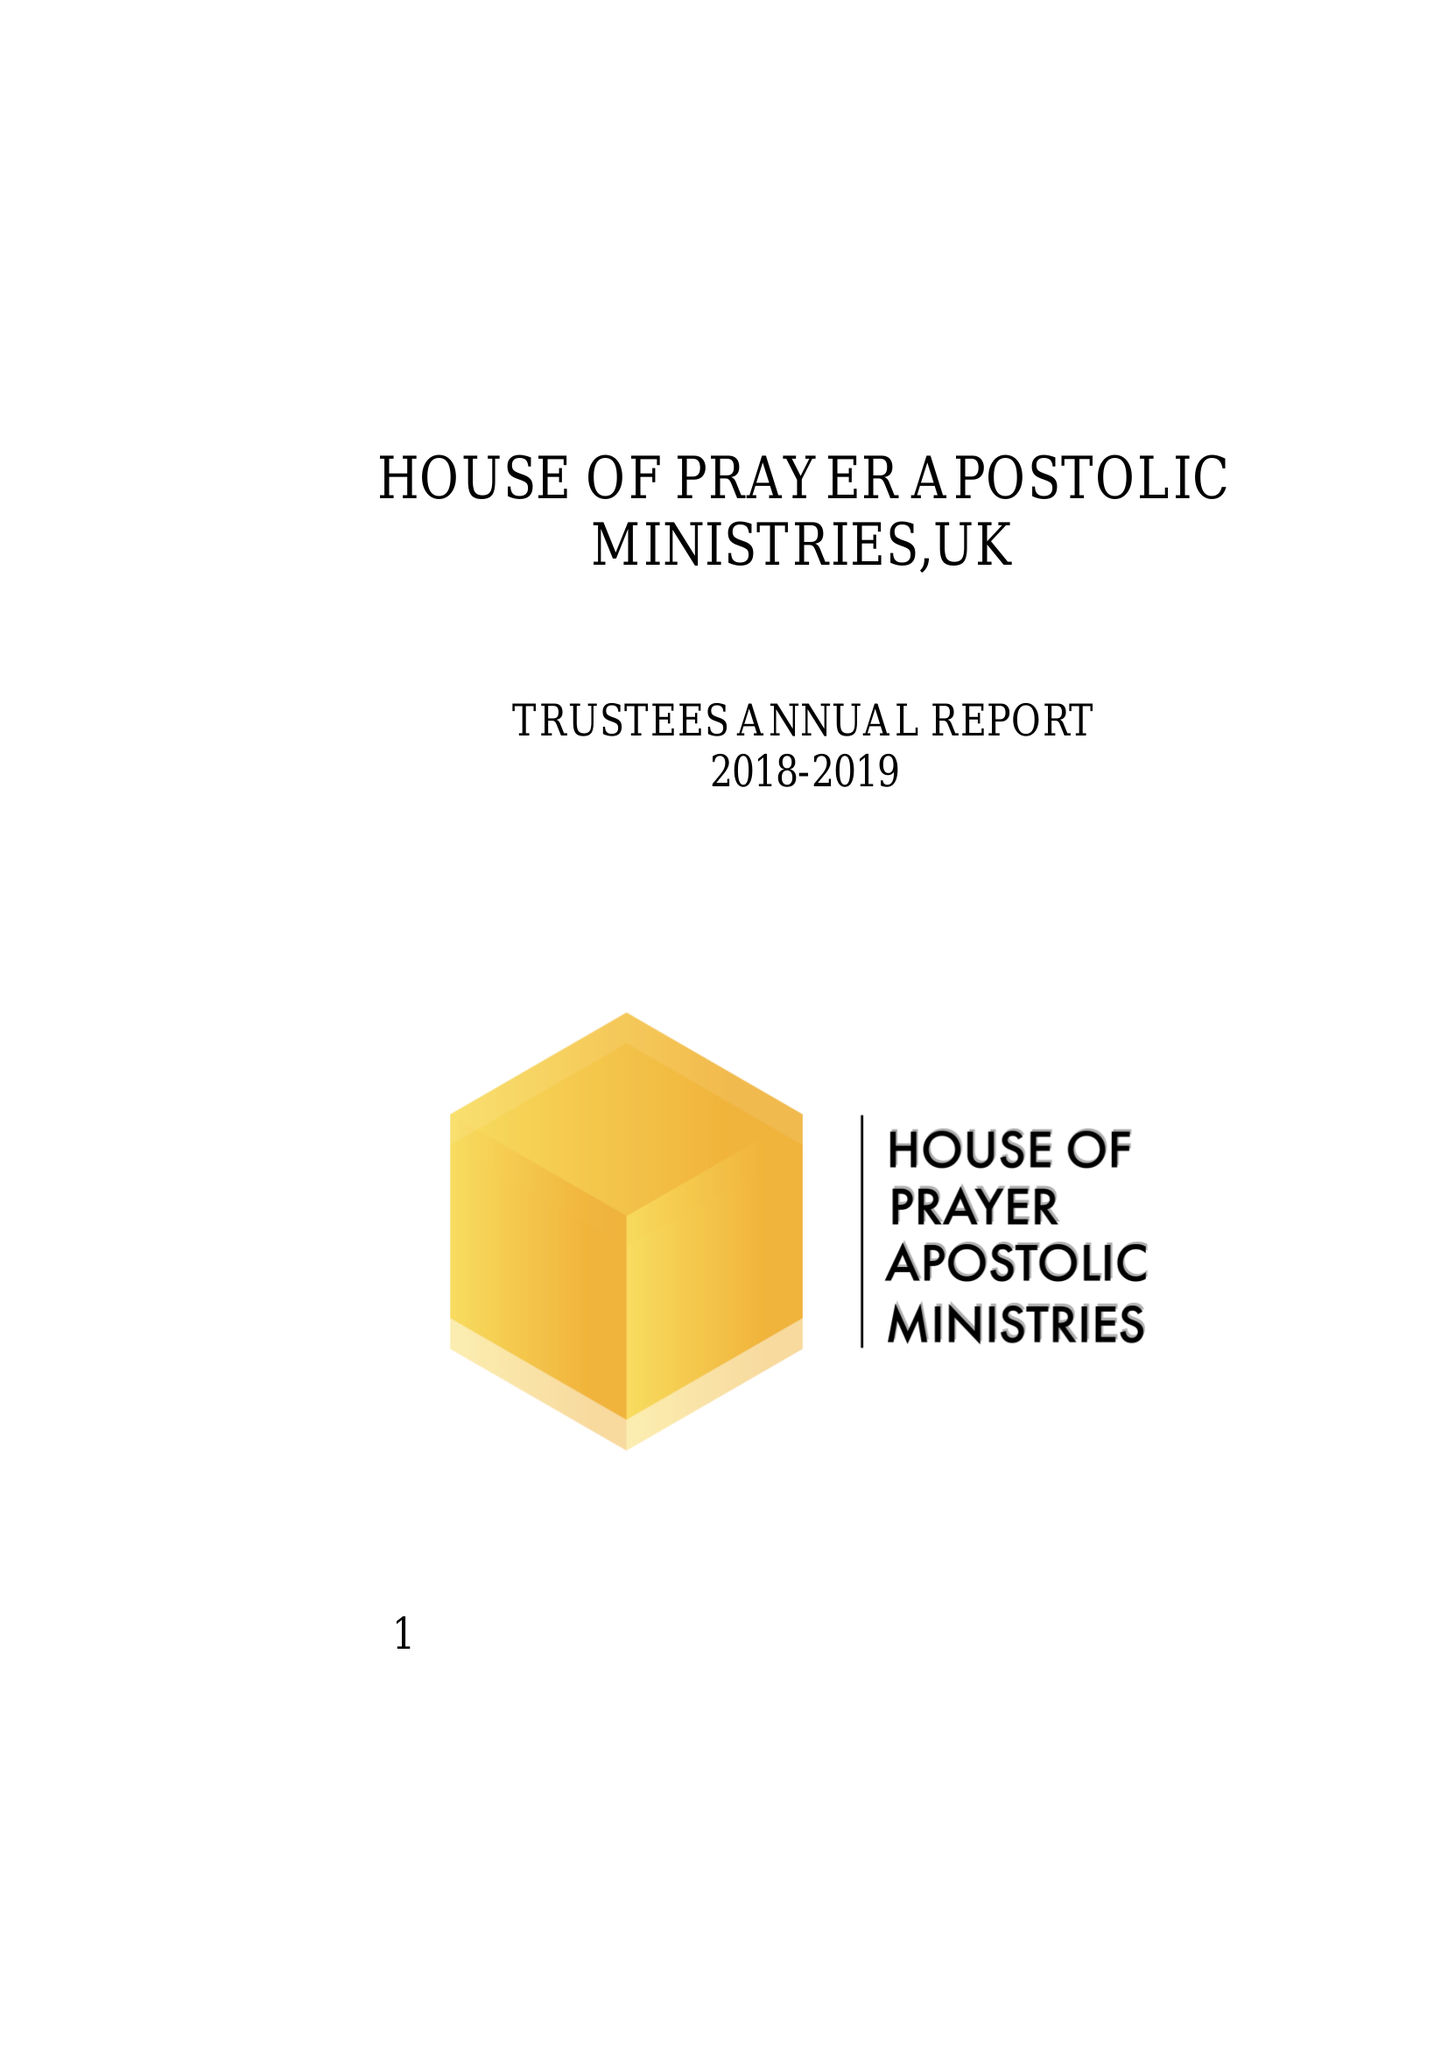What is the value for the spending_annually_in_british_pounds?
Answer the question using a single word or phrase. 20570.00 